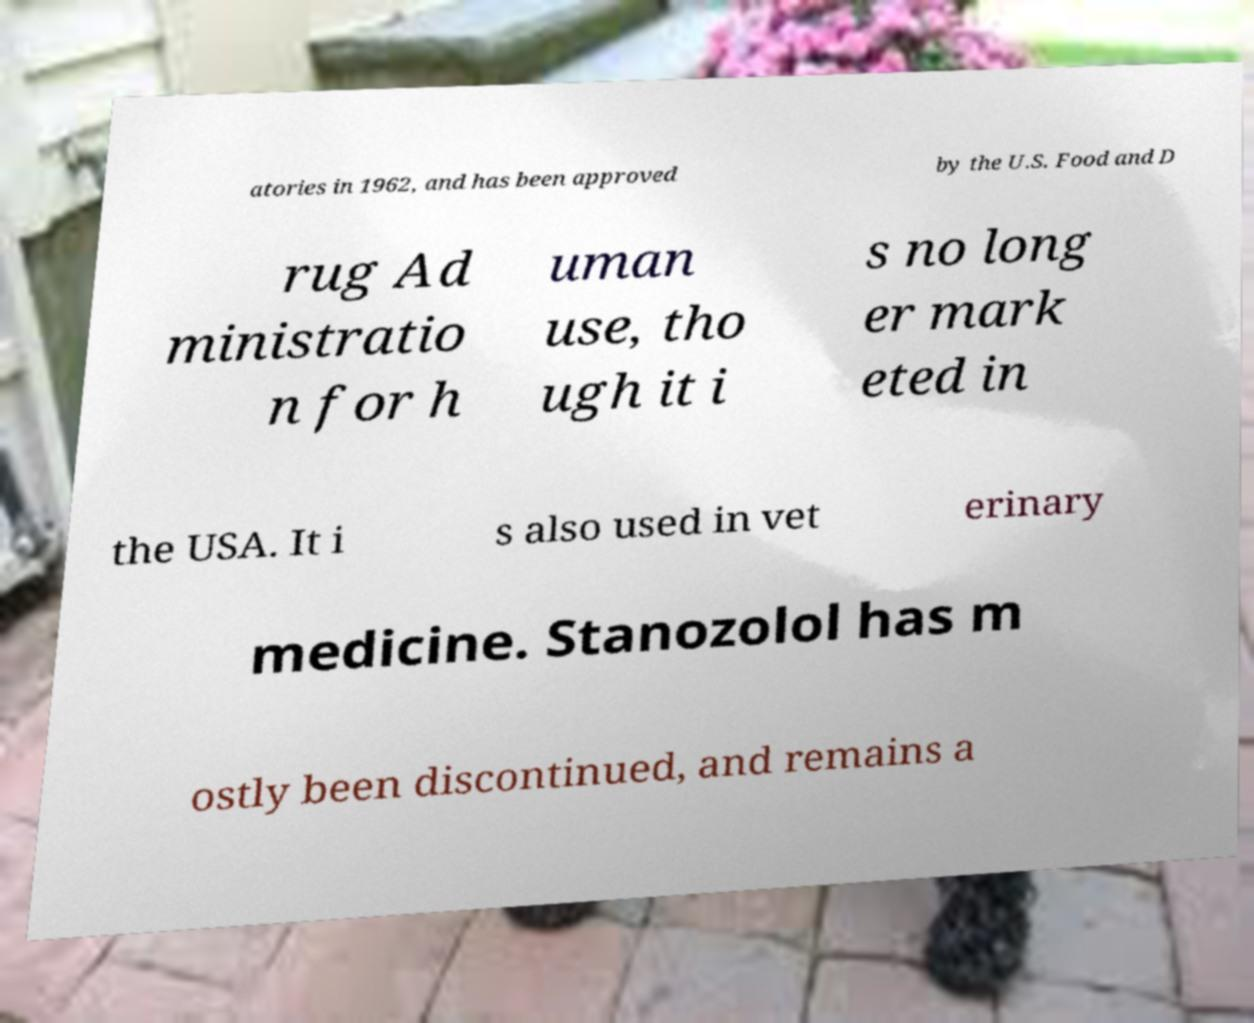Could you extract and type out the text from this image? atories in 1962, and has been approved by the U.S. Food and D rug Ad ministratio n for h uman use, tho ugh it i s no long er mark eted in the USA. It i s also used in vet erinary medicine. Stanozolol has m ostly been discontinued, and remains a 